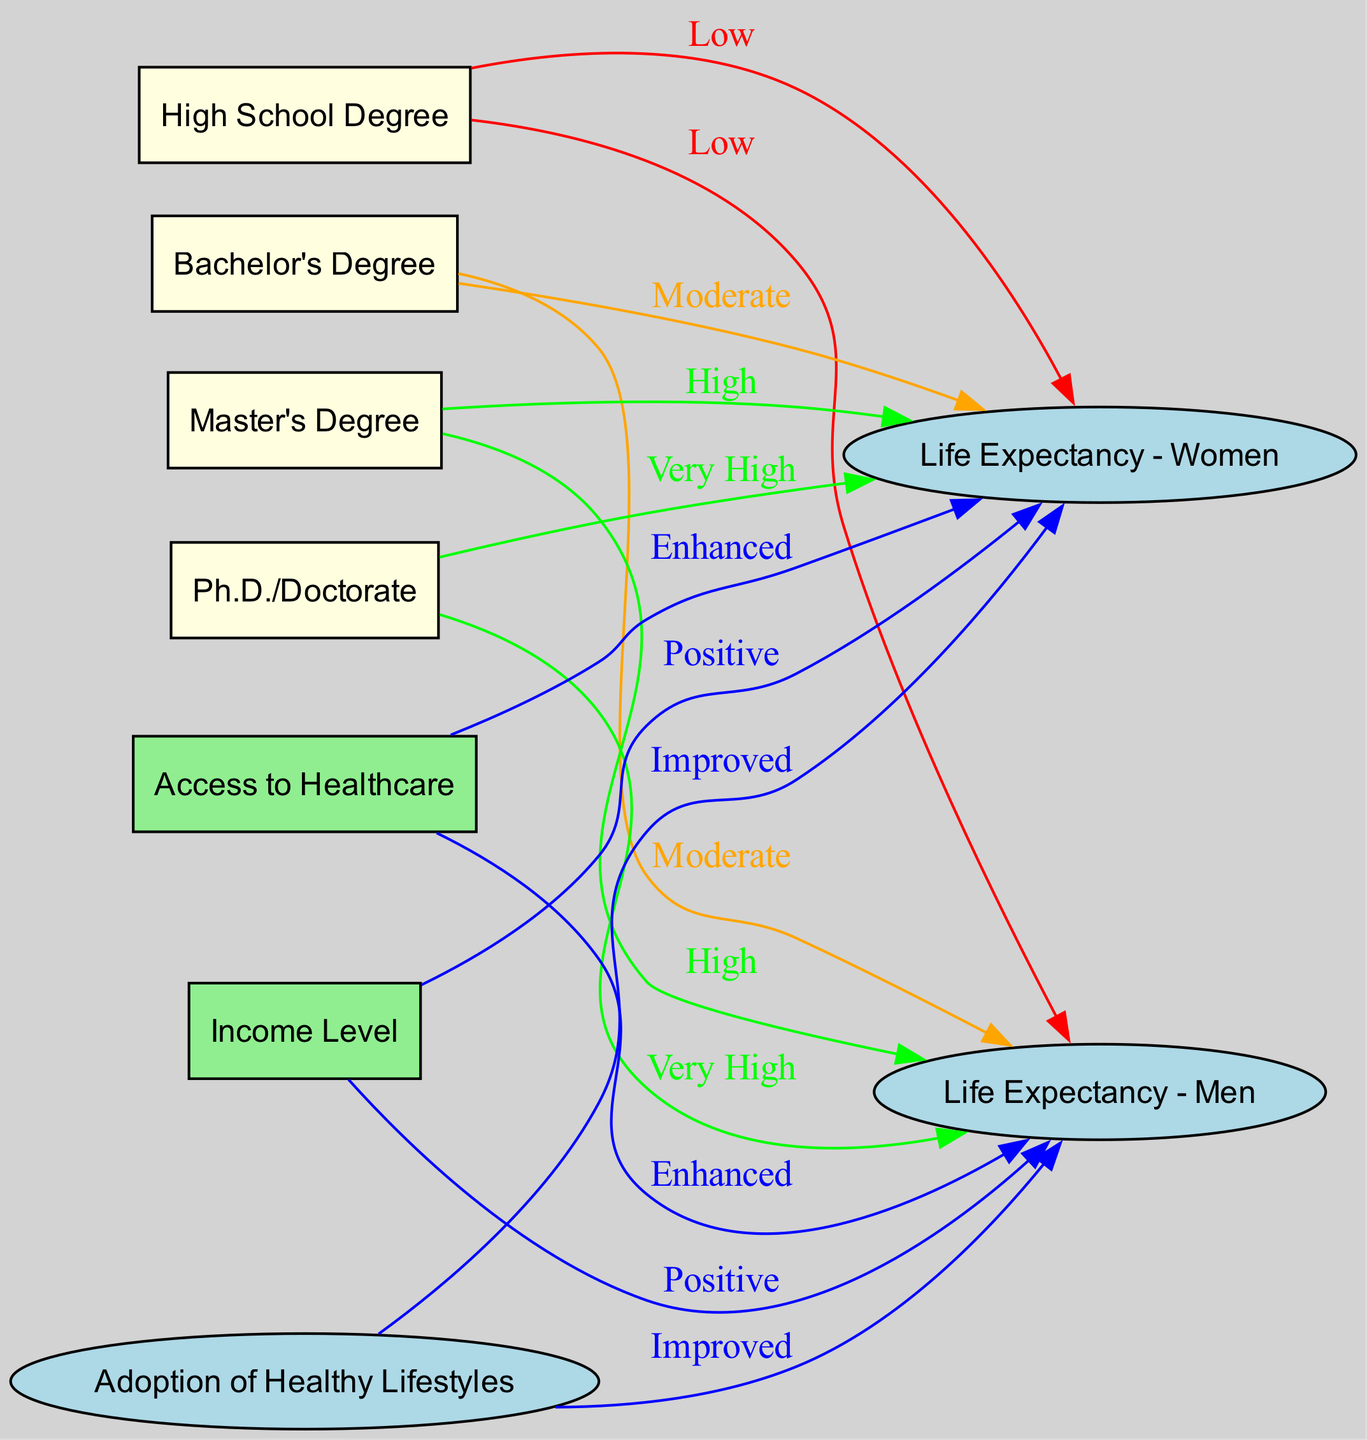What is the relationship labeled between "High School Degree" and "Life Expectancy - Men"? The diagram indicates a "Low" relationship between "High School Degree" and "Life Expectancy - Men", which is depicted with a red edge showing the type of connection.
Answer: Low How many edges are connected to "Ph.D./Doctorate"? "Ph.D./Doctorate" has two edges connected to it: one leading to "Life Expectancy - Men" and another to "Life Expectancy - Women". The diagram visually represents these connections.
Answer: 2 What is the label of the relationship between "Masters" and "Life Expectancy - Women"? The diagram displays a "High" relationship between "Masters" and "Life Expectancy - Women", indicated by a green-colored edge that reflects the positive nature of this connection.
Answer: High Which educational attainment level is associated with the "Very High" life expectancy for both genders? The "Ph.D./Doctorate" node is linked by "Very High" labeled edges to both "Life Expectancy - Men" and "Life Expectancy - Women". This shows that attaining a Ph.D. typically leads to higher life expectancy.
Answer: Ph.D./Doctorate Which factor shows a "Positive" impact on life expectancy for both men and women? The "Income Level" node is depicted with edges labeled "Positive" leading to both "Life Expectancy - Men" and "Life Expectancy - Women", indicating that higher income levels are associated with increased life expectancy.
Answer: Income Level How does "Access to Healthcare" impact life expectancy according to the diagram? "Access to Healthcare" is shown to have an "Enhanced" relationship with both "Life Expectancy - Men" and "Life Expectancy - Women". This means that improved access to healthcare is positively correlated with life expectancy for both genders.
Answer: Enhanced What trend is observed from "High School Degree" to higher educational levels in terms of life expectancy? The diagram reveals that as one progresses from "High School Degree" to "Bachelors", "Masters", and finally "Ph.D./Doctorate", the life expectancy increases from "Low" to "Very High". This shows a clear trend of improvement in life expectancy with higher education.
Answer: Increases What color represents a "Moderate" relationship in the diagram? The color orange is used to illustrate "Moderate" relationships in the diagram, specifically between "Bachelors" and both "Life Expectancy - Men" and "Life Expectancy - Women".
Answer: Orange 